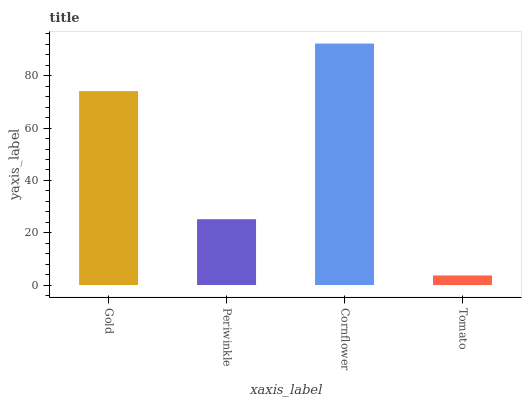Is Tomato the minimum?
Answer yes or no. Yes. Is Cornflower the maximum?
Answer yes or no. Yes. Is Periwinkle the minimum?
Answer yes or no. No. Is Periwinkle the maximum?
Answer yes or no. No. Is Gold greater than Periwinkle?
Answer yes or no. Yes. Is Periwinkle less than Gold?
Answer yes or no. Yes. Is Periwinkle greater than Gold?
Answer yes or no. No. Is Gold less than Periwinkle?
Answer yes or no. No. Is Gold the high median?
Answer yes or no. Yes. Is Periwinkle the low median?
Answer yes or no. Yes. Is Tomato the high median?
Answer yes or no. No. Is Tomato the low median?
Answer yes or no. No. 